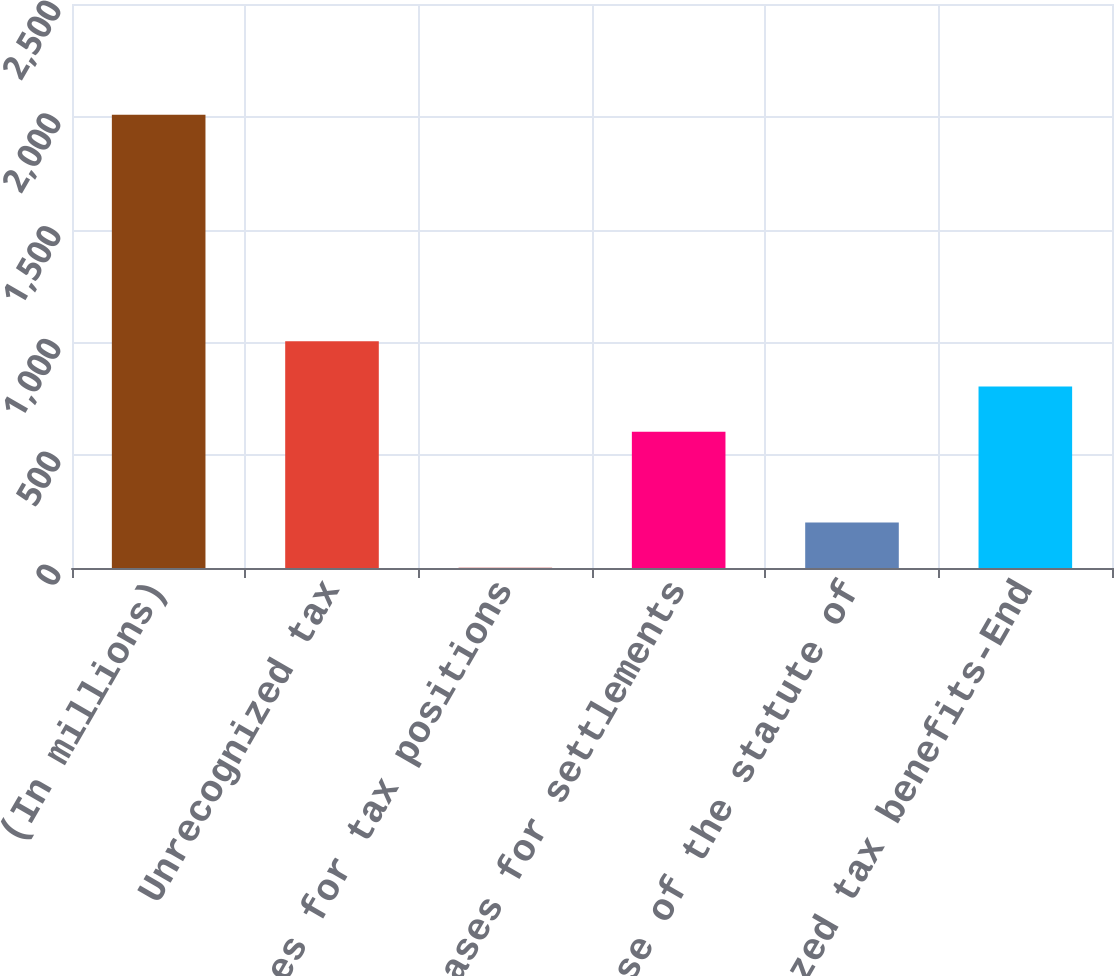Convert chart to OTSL. <chart><loc_0><loc_0><loc_500><loc_500><bar_chart><fcel>(In millions)<fcel>Unrecognized tax<fcel>Increases for tax positions<fcel>Decreases for settlements<fcel>Lapse of the statute of<fcel>Unrecognized tax benefits-End<nl><fcel>2009<fcel>1005<fcel>1<fcel>603.4<fcel>201.8<fcel>804.2<nl></chart> 